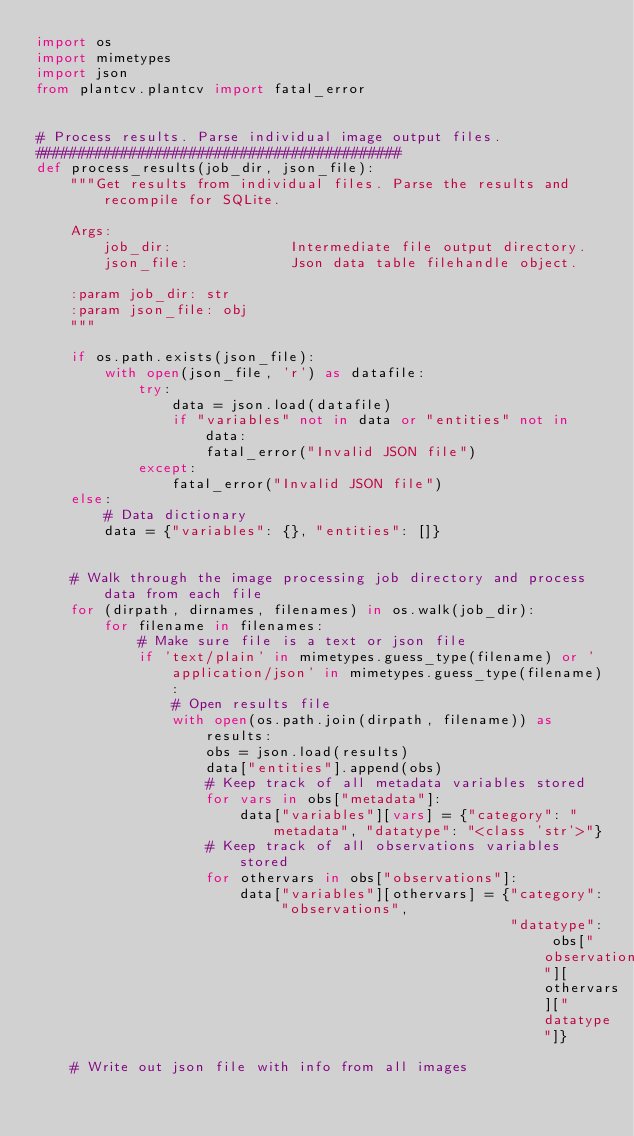<code> <loc_0><loc_0><loc_500><loc_500><_Python_>import os
import mimetypes
import json
from plantcv.plantcv import fatal_error


# Process results. Parse individual image output files.
###########################################
def process_results(job_dir, json_file):
    """Get results from individual files. Parse the results and recompile for SQLite.

    Args:
        job_dir:              Intermediate file output directory.
        json_file:            Json data table filehandle object.

    :param job_dir: str
    :param json_file: obj
    """

    if os.path.exists(json_file):
        with open(json_file, 'r') as datafile:
            try:
                data = json.load(datafile)
                if "variables" not in data or "entities" not in data:
                    fatal_error("Invalid JSON file")
            except:
                fatal_error("Invalid JSON file")
    else:
        # Data dictionary
        data = {"variables": {}, "entities": []}


    # Walk through the image processing job directory and process data from each file
    for (dirpath, dirnames, filenames) in os.walk(job_dir):
        for filename in filenames:
            # Make sure file is a text or json file
            if 'text/plain' in mimetypes.guess_type(filename) or 'application/json' in mimetypes.guess_type(filename):
                # Open results file
                with open(os.path.join(dirpath, filename)) as results:
                    obs = json.load(results)
                    data["entities"].append(obs)
                    # Keep track of all metadata variables stored
                    for vars in obs["metadata"]:
                        data["variables"][vars] = {"category": "metadata", "datatype": "<class 'str'>"}
                    # Keep track of all observations variables stored
                    for othervars in obs["observations"]:
                        data["variables"][othervars] = {"category": "observations",
                                                        "datatype": obs["observations"][othervars]["datatype"]}

    # Write out json file with info from all images</code> 